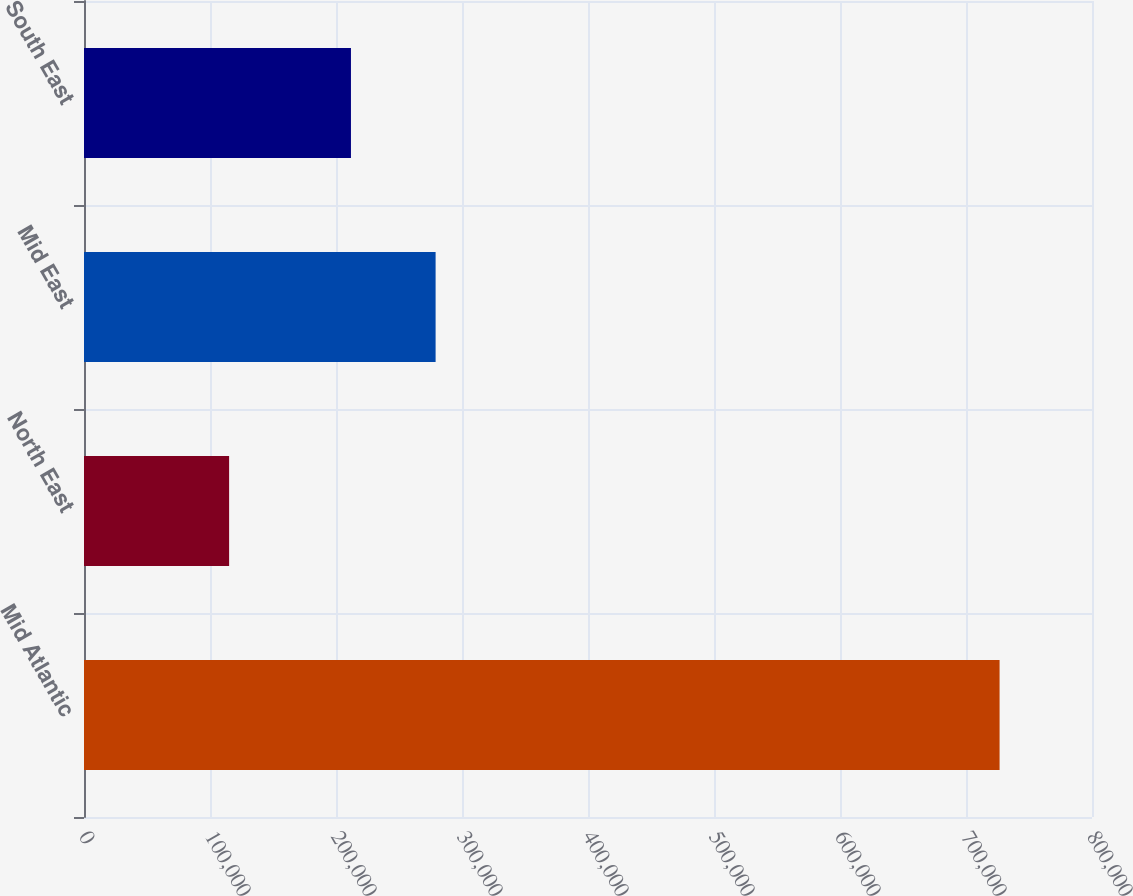<chart> <loc_0><loc_0><loc_500><loc_500><bar_chart><fcel>Mid Atlantic<fcel>North East<fcel>Mid East<fcel>South East<nl><fcel>726655<fcel>115169<fcel>279050<fcel>211870<nl></chart> 